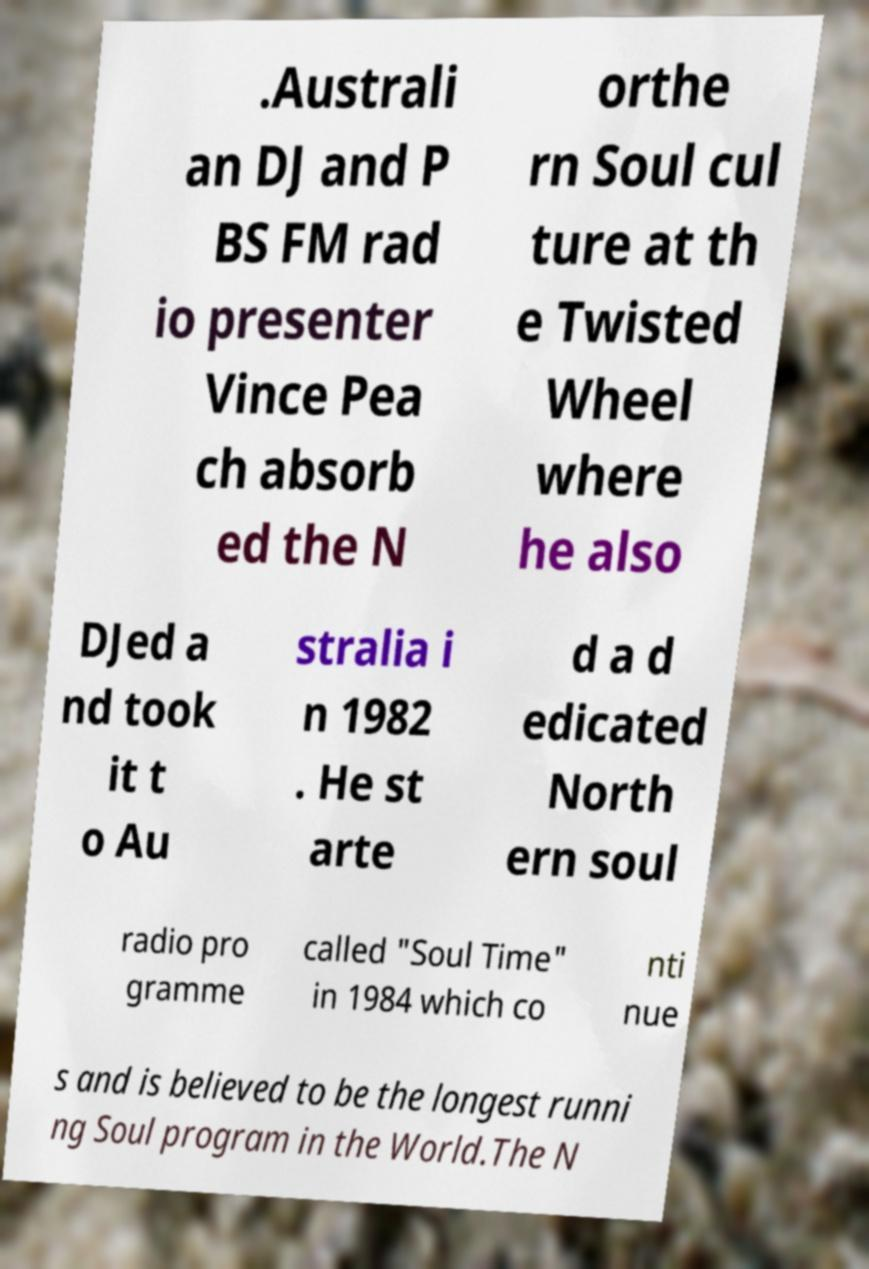Can you read and provide the text displayed in the image?This photo seems to have some interesting text. Can you extract and type it out for me? .Australi an DJ and P BS FM rad io presenter Vince Pea ch absorb ed the N orthe rn Soul cul ture at th e Twisted Wheel where he also DJed a nd took it t o Au stralia i n 1982 . He st arte d a d edicated North ern soul radio pro gramme called "Soul Time" in 1984 which co nti nue s and is believed to be the longest runni ng Soul program in the World.The N 